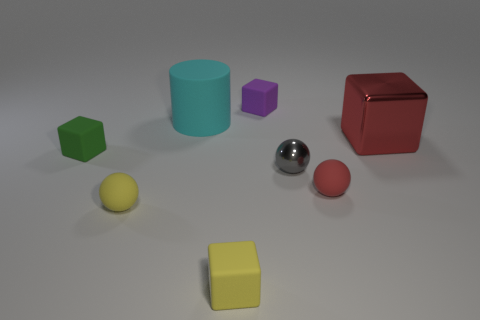There is a cyan rubber cylinder that is to the left of the gray metal sphere; does it have the same size as the rubber block behind the large metal object?
Your answer should be very brief. No. What number of big metal cylinders are there?
Offer a terse response. 0. How big is the block left of the small ball that is left of the small yellow matte thing to the right of the large cylinder?
Offer a terse response. Small. There is a yellow cube; what number of large red metallic blocks are in front of it?
Give a very brief answer. 0. Are there the same number of big red shiny cubes in front of the tiny yellow ball and tiny cyan cylinders?
Your answer should be very brief. Yes. What number of things are either yellow metallic spheres or small purple objects?
Provide a succinct answer. 1. Is there anything else that has the same shape as the large cyan thing?
Provide a short and direct response. No. The thing in front of the small rubber sphere that is to the left of the yellow cube is what shape?
Keep it short and to the point. Cube. What is the shape of the cyan object that is the same material as the small purple thing?
Provide a short and direct response. Cylinder. What size is the metal block on the right side of the red thing in front of the green thing?
Provide a short and direct response. Large. 